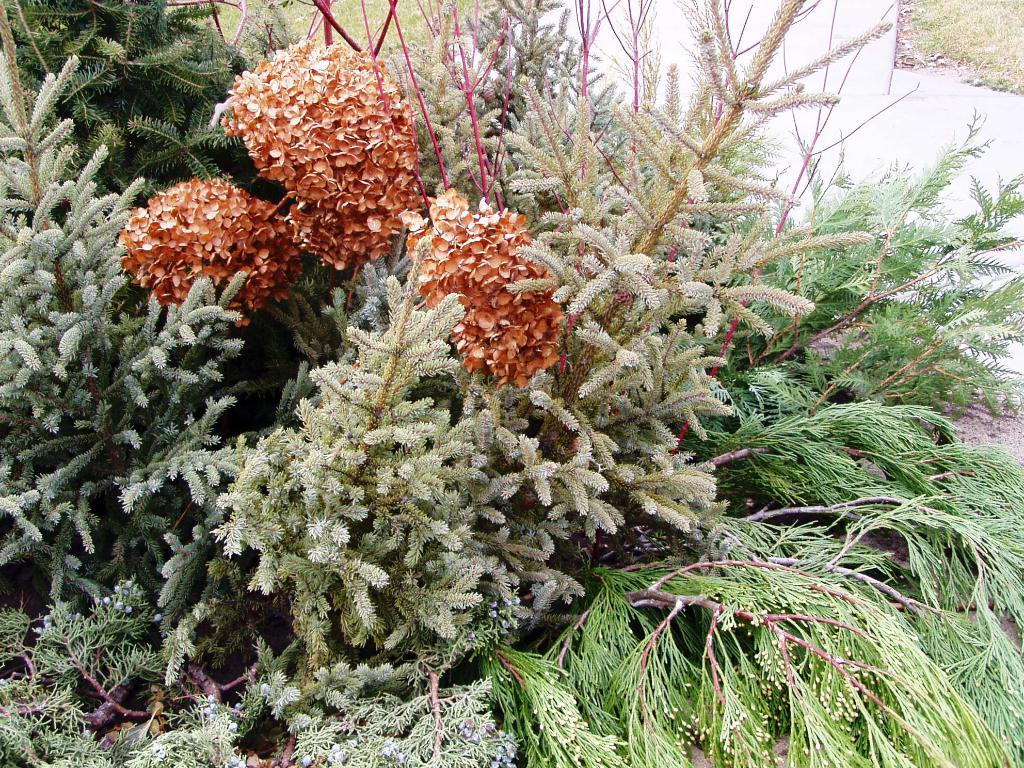What type of flora can be seen in the image? There are flowers and plants in the image. What is the color of the flowers in the image? The flowers in the image are orange in color. What is the color of the plants in the image? The plants in the image are green in color. What type of unit can be seen in the image? There is no unit present in the image; it features flowers and plants. What type of loaf is being used to water the plants in the image? There is no loaf present in the image, and the plants are not being watered. 